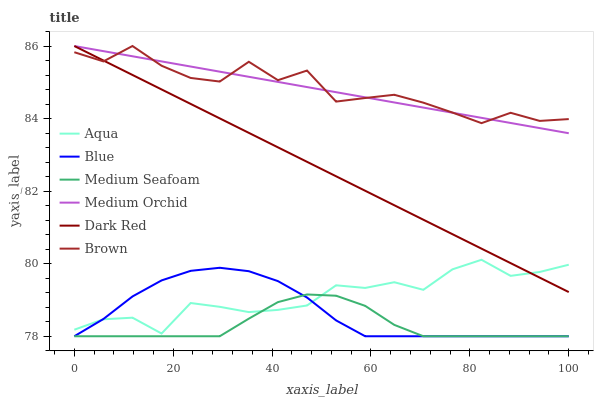Does Medium Seafoam have the minimum area under the curve?
Answer yes or no. Yes. Does Brown have the maximum area under the curve?
Answer yes or no. Yes. Does Dark Red have the minimum area under the curve?
Answer yes or no. No. Does Dark Red have the maximum area under the curve?
Answer yes or no. No. Is Dark Red the smoothest?
Answer yes or no. Yes. Is Brown the roughest?
Answer yes or no. Yes. Is Brown the smoothest?
Answer yes or no. No. Is Dark Red the roughest?
Answer yes or no. No. Does Blue have the lowest value?
Answer yes or no. Yes. Does Dark Red have the lowest value?
Answer yes or no. No. Does Medium Orchid have the highest value?
Answer yes or no. Yes. Does Aqua have the highest value?
Answer yes or no. No. Is Aqua less than Brown?
Answer yes or no. Yes. Is Medium Orchid greater than Medium Seafoam?
Answer yes or no. Yes. Does Aqua intersect Dark Red?
Answer yes or no. Yes. Is Aqua less than Dark Red?
Answer yes or no. No. Is Aqua greater than Dark Red?
Answer yes or no. No. Does Aqua intersect Brown?
Answer yes or no. No. 